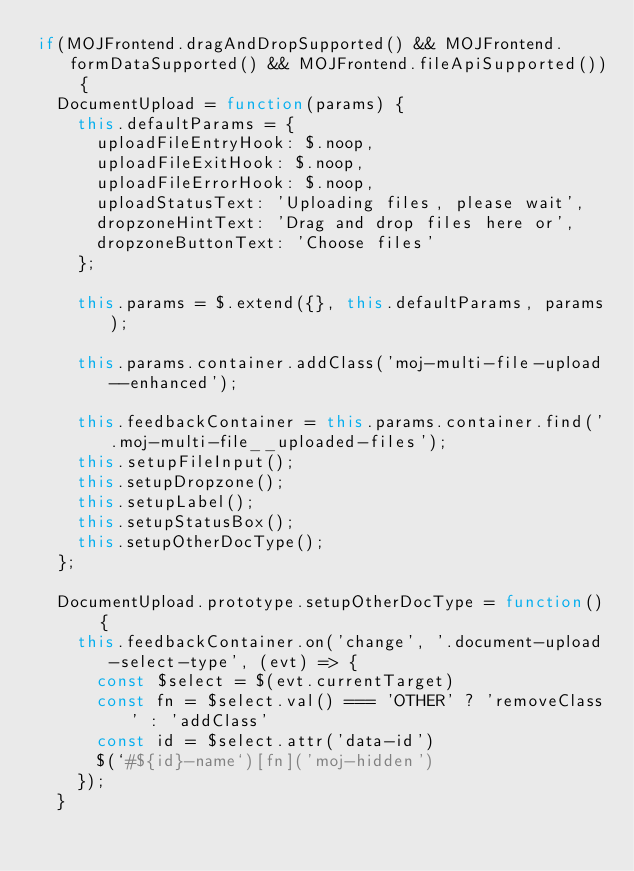Convert code to text. <code><loc_0><loc_0><loc_500><loc_500><_JavaScript_>if(MOJFrontend.dragAndDropSupported() && MOJFrontend.formDataSupported() && MOJFrontend.fileApiSupported()) {
  DocumentUpload = function(params) {
    this.defaultParams = {
      uploadFileEntryHook: $.noop,
      uploadFileExitHook: $.noop,
      uploadFileErrorHook: $.noop,
      uploadStatusText: 'Uploading files, please wait',
      dropzoneHintText: 'Drag and drop files here or',
      dropzoneButtonText: 'Choose files'
    };

    this.params = $.extend({}, this.defaultParams, params);

    this.params.container.addClass('moj-multi-file-upload--enhanced');

    this.feedbackContainer = this.params.container.find('.moj-multi-file__uploaded-files');
    this.setupFileInput();
    this.setupDropzone();
    this.setupLabel();
    this.setupStatusBox();
    this.setupOtherDocType();
  };

  DocumentUpload.prototype.setupOtherDocType = function() {
    this.feedbackContainer.on('change', '.document-upload-select-type', (evt) => {
      const $select = $(evt.currentTarget)
      const fn = $select.val() === 'OTHER' ? 'removeClass' : 'addClass'
      const id = $select.attr('data-id')
      $(`#${id}-name`)[fn]('moj-hidden')
    });
  }
</code> 